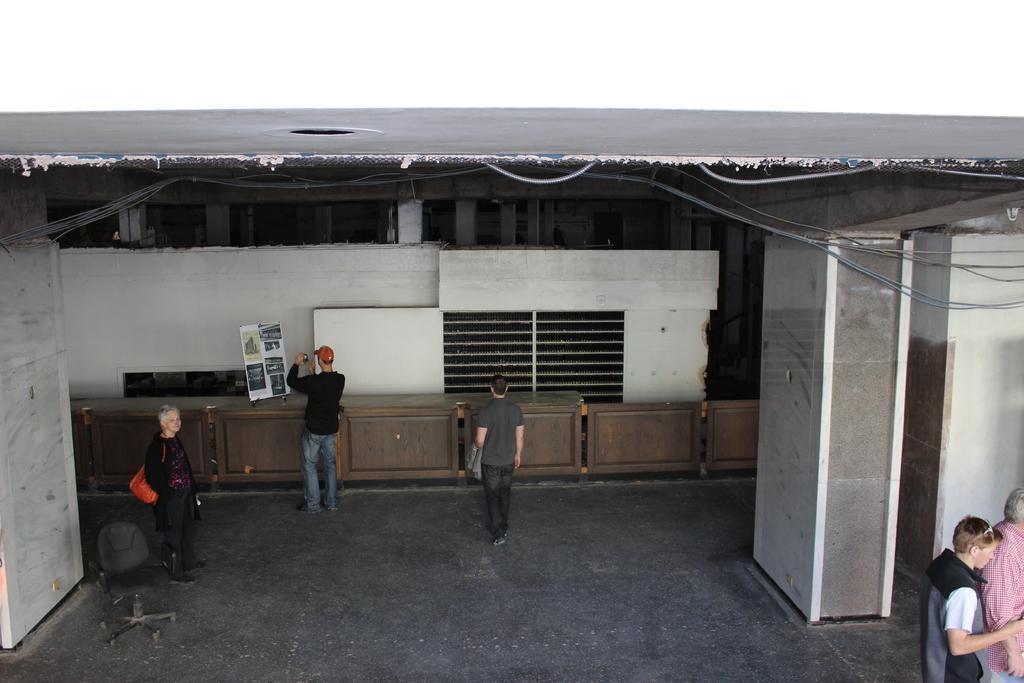Could you give a brief overview of what you see in this image? In this image at front people are standing on the floor. At the background there is a building. 